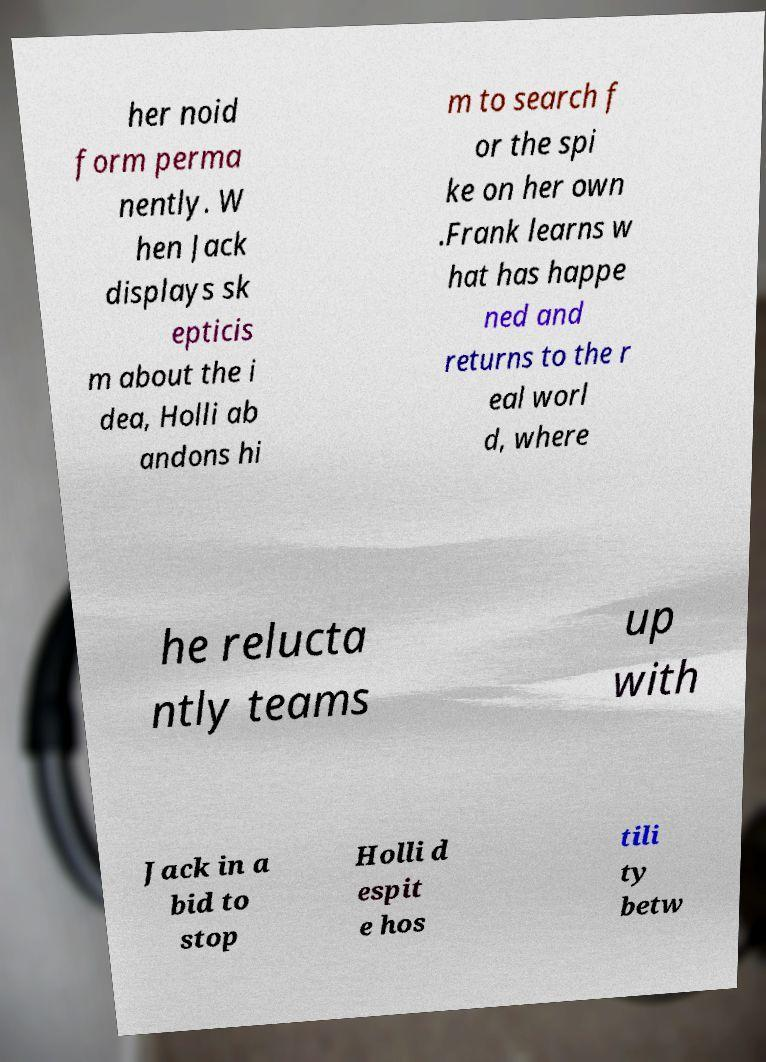Could you extract and type out the text from this image? her noid form perma nently. W hen Jack displays sk epticis m about the i dea, Holli ab andons hi m to search f or the spi ke on her own .Frank learns w hat has happe ned and returns to the r eal worl d, where he relucta ntly teams up with Jack in a bid to stop Holli d espit e hos tili ty betw 